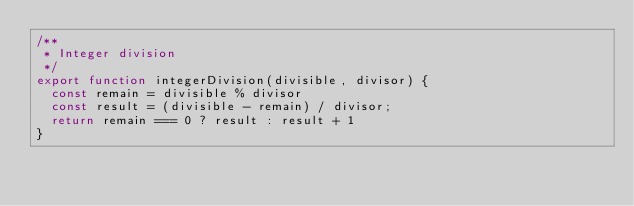<code> <loc_0><loc_0><loc_500><loc_500><_TypeScript_>/**
 * Integer division
 */
export function integerDivision(divisible, divisor) {
  const remain = divisible % divisor
  const result = (divisible - remain) / divisor;
  return remain === 0 ? result : result + 1
}
</code> 